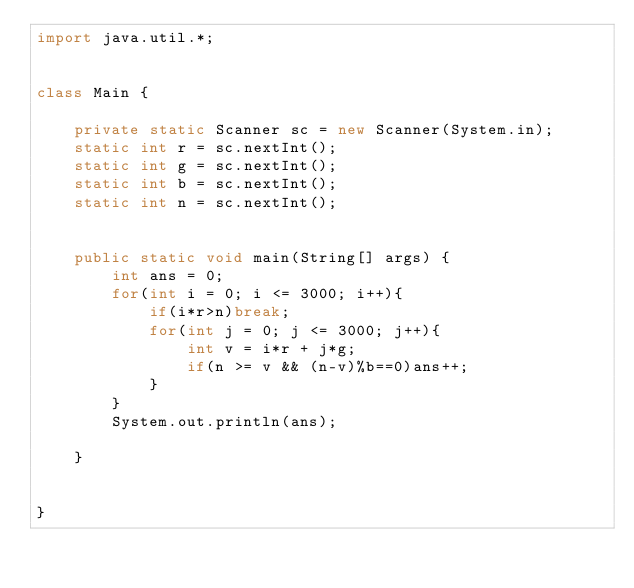Convert code to text. <code><loc_0><loc_0><loc_500><loc_500><_Java_>import java.util.*;

 
class Main {
 
    private static Scanner sc = new Scanner(System.in);
    static int r = sc.nextInt();
    static int g = sc.nextInt();
    static int b = sc.nextInt();
    static int n = sc.nextInt();


    public static void main(String[] args) {
        int ans = 0;
        for(int i = 0; i <= 3000; i++){
            if(i*r>n)break;
            for(int j = 0; j <= 3000; j++){
                int v = i*r + j*g;
                if(n >= v && (n-v)%b==0)ans++;
            }
        }  
        System.out.println(ans);     

    }


}
</code> 